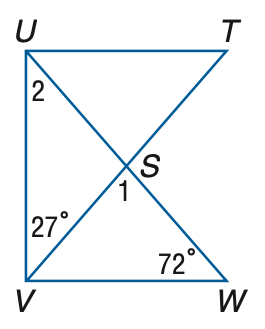Question: If T U \perp U V and U V \perp V W, find m \angle 1.
Choices:
A. 45
B. 47
C. 52
D. 55
Answer with the letter. Answer: A 